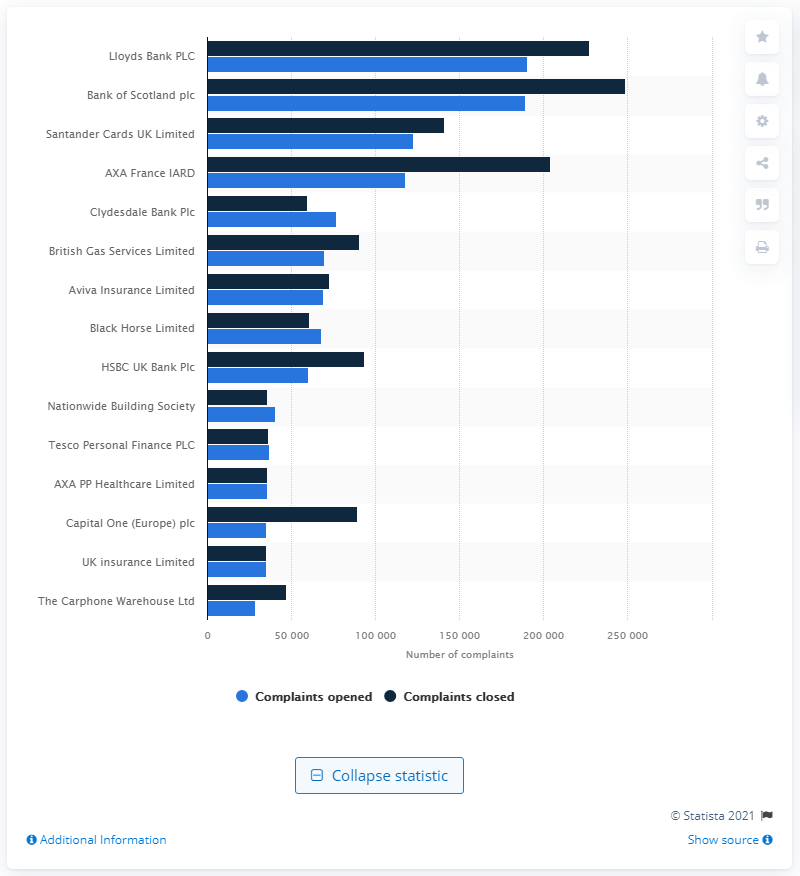Indicate a few pertinent items in this graphic. The largest number of customer complaints in the first half of 2020 was received by Lloyds Bank PLC. 